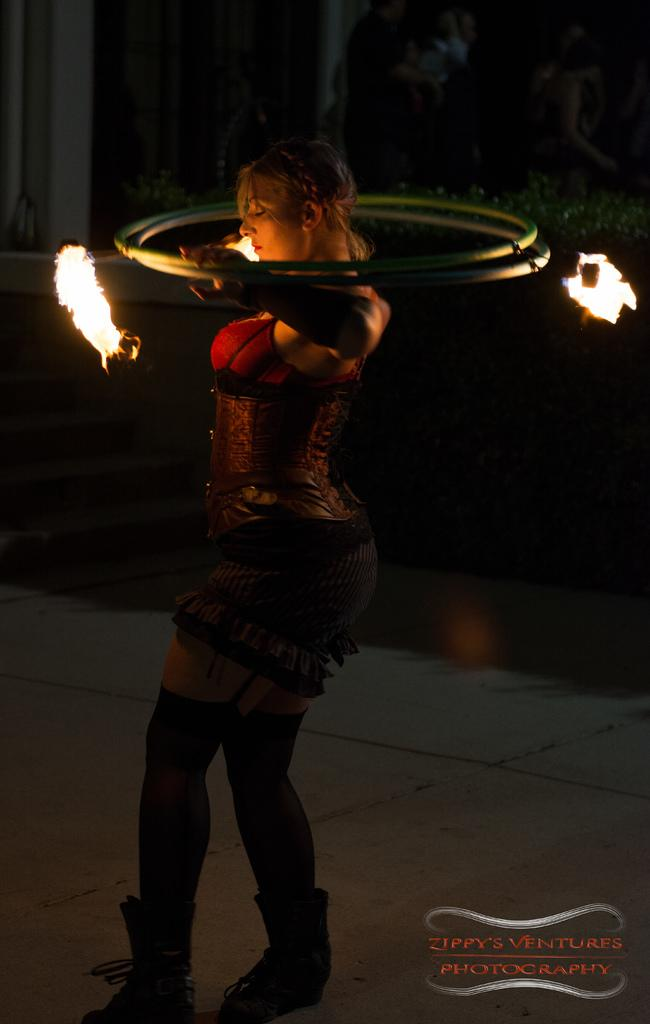Who is the main subject in the image? There is a woman in the image. What is the woman doing in the image? The woman is standing in the image. What is the woman holding in the image? The woman is holding two rings in the image. What is attached to the rings? There are three fire objects attached to the rings. What type of lettuce is the woman thinking about in the image? There is no lettuce present in the image, nor is there any indication that the woman is thinking about lettuce. 